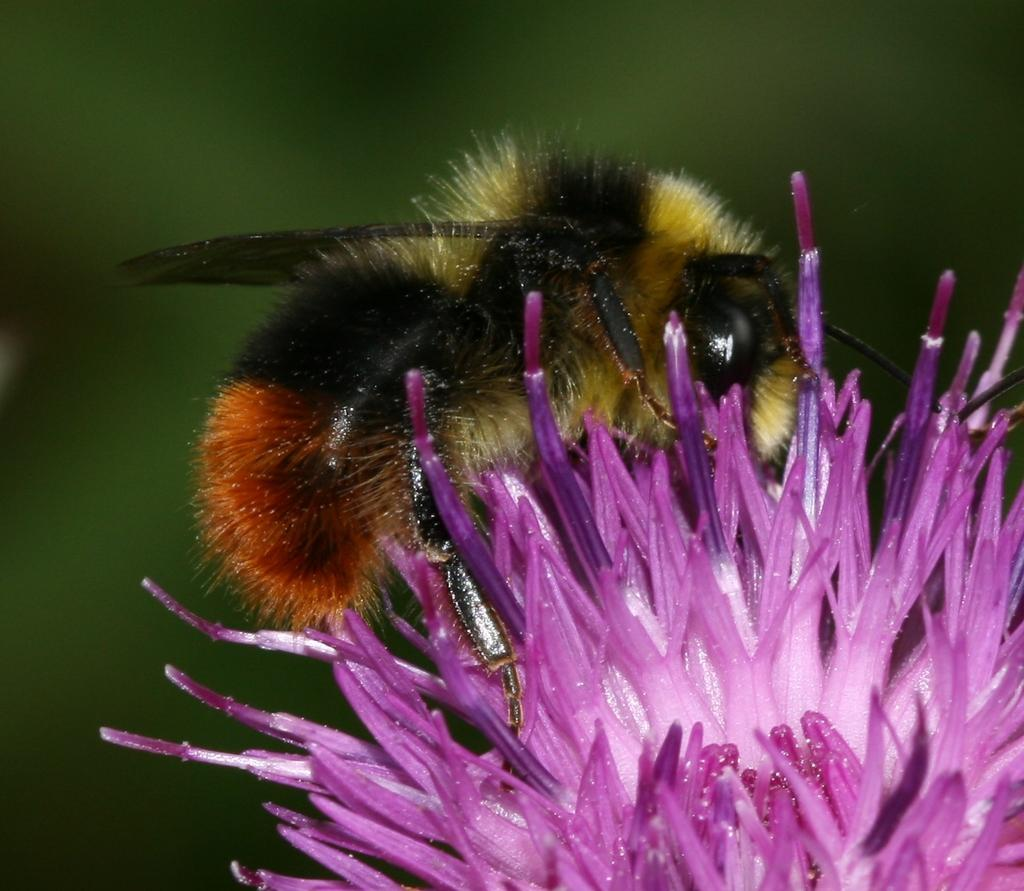What is the main subject of the image? There is a flower in the image. Is there anything else present on the flower? Yes, a bee is sitting on the flower. What color is the background of the image? The background of the image is green. Where might this image have been taken? The image may have been taken in a garden, given the presence of a flower and the green background. What type of crayon can be seen in the image? There is no crayon present in the image. Is the brass visible in the image? There is no brass visible in the image. 